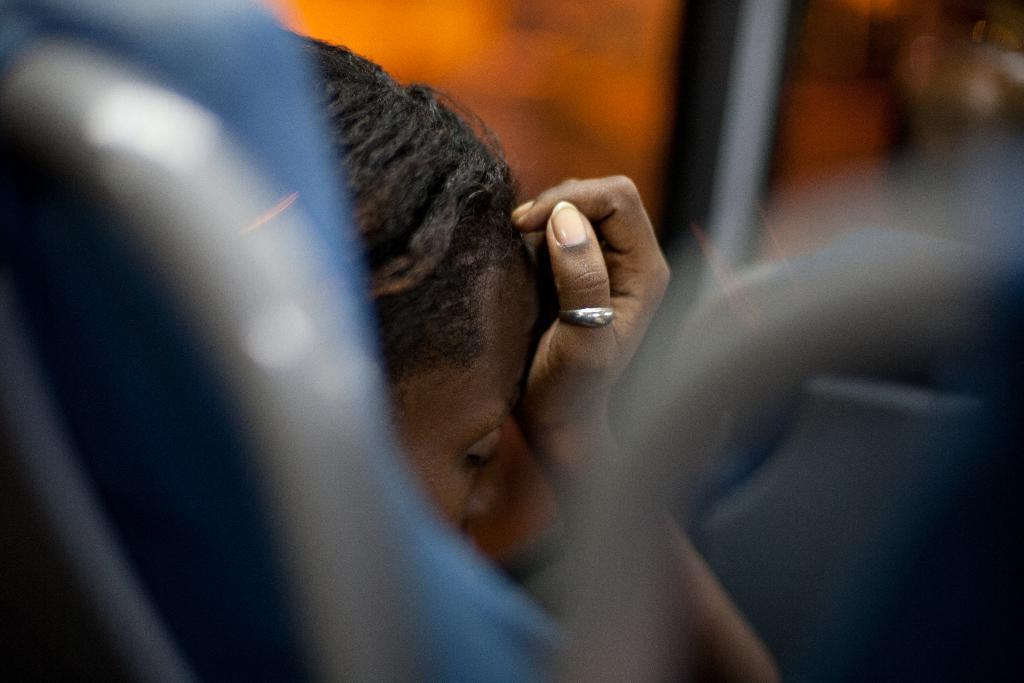Could you give a brief overview of what you see in this image? In the picture we can see a person sitting and keeping a hand to the head. 